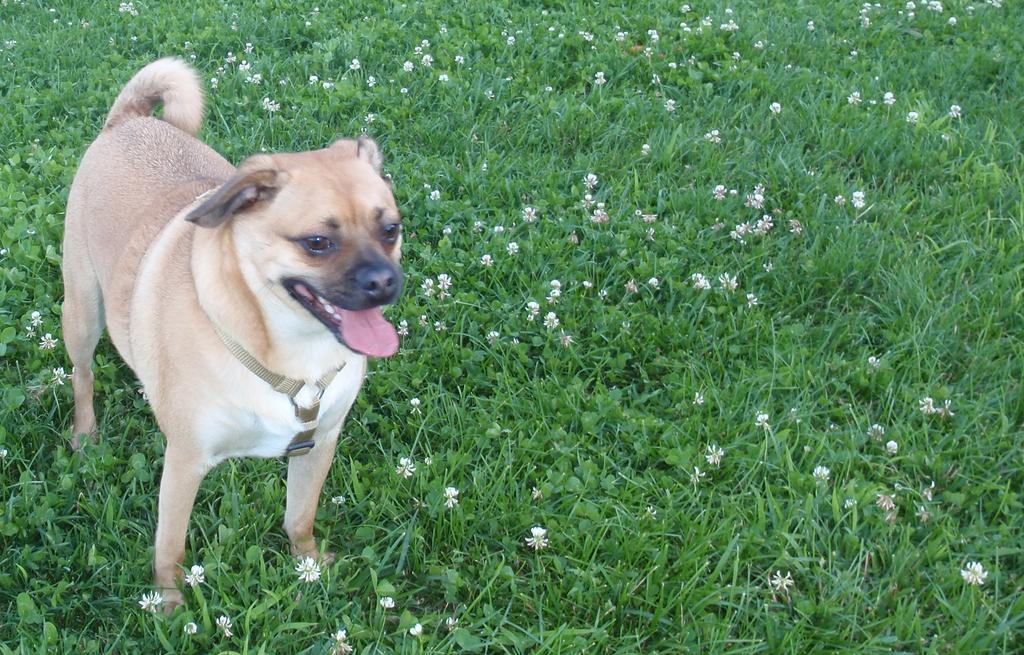What type of animal is in the image? There is a dog in the image. What is the dog's position in relation to the ground? The dog is standing on the ground. What can be found on the ground besides the dog? There are flowers and grass on the ground. What color is the sky in the image? The provided facts do not mention the sky or its color, so we cannot determine the color of the sky from the image. 